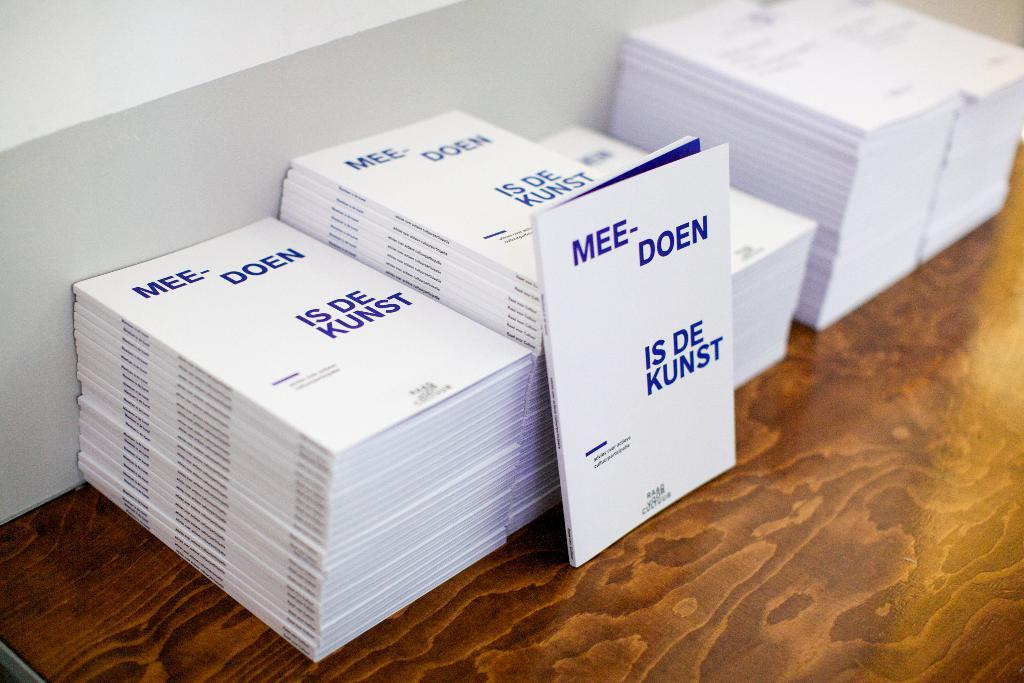Provide a one-sentence caption for the provided image. Mee Doen is de Kunst booklets stacked on top of each other. 